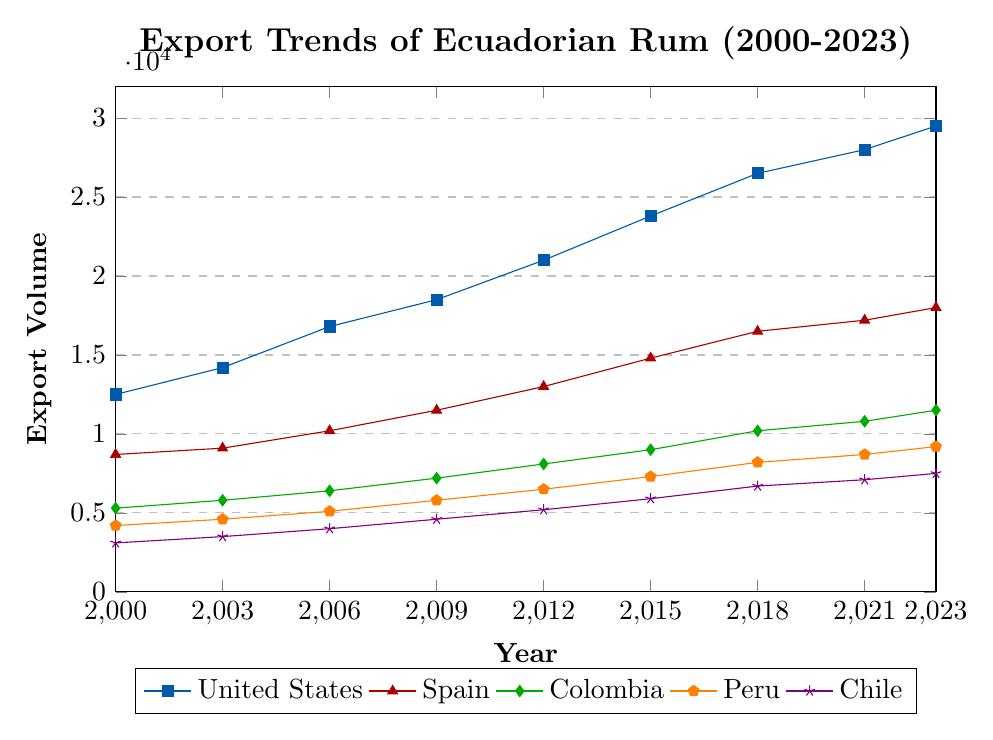What's the overall trend for the export volumes to the United States from 2000 to 2023? First, identify the data points for the United States over the years (e.g., 12500 in 2000, 29500 in 2023). Then, observe the overall increase of the export volumes from the initial value to the final value over the given time period. The trend is clearly increasing.
Answer: Increasing Which country had the least export volume in 2000, and what was that volume? Look at the data points for all countries in the year 2000 (12500 for the US, 8700 for Spain, 5300 for Colombia, 4200 for Peru, and 3100 for Chile). The smallest value is for Chile.
Answer: Chile, 3100 How much did the export volume to Colombia increase from 2000 to 2023? Identify the export volumes to Colombia in 2000 (5300) and 2023 (11500). Calculate the difference: 11500 - 5300 = 6200.
Answer: 6200 Which country experienced the largest increase in export volume from 2000 to 2023? Calculate the increase for each country by subtracting the values in 2000 from the values in 2023. For the US, 29500 - 12500 = 17000; for Spain, 18000 - 8700 = 9300; for Colombia, 11500 - 5300 = 6200; for Peru, 9200 - 4200 = 5000; for Chile, 7500 - 3100 = 4400. The largest increase is for the United States.
Answer: United States In which year did exports to Spain first exceed 15000 units? Identify the data points for Spain and find the first year where the value exceeds 15000. The value exceeds 15000 in 2015, where it is 14800 which is very close, so check the next data point in 2018 which is 16500.
Answer: 2018 What is the average export volume to Peru over the years provided? Sum the export volumes for Peru for all given years: 4200 + 4600 + 5100 + 5800 + 6500 + 7300 + 8200 + 8700 + 9200 = 59400. Divide by the number of data points (9): 59400 / 9 = 6600.
Answer: 6600 Compare the export volumes to Spain and Colombia in 2012. Which one is higher and by how much? Check the figures for the year 2012: Spain's volume is 13000 and Colombia's is 8100. Calculate the difference: 13000 - 8100 = 4900. Spain’s export volume is higher by 4900 units.
Answer: Spain, by 4900 Did the export volumes to Chile ever exceed 8000 units in the given time period? Look at the data points for Chile over the years. The highest value is 7500 in 2023.
Answer: No In 2023, what is the total export volume to all the listed countries? Sum up the export volumes for all countries in the year 2023: 29500 (US) + 18000 (Spain) + 11500 (Colombia) + 9200 (Peru) + 7500 (Chile) = 75700.
Answer: 75700 